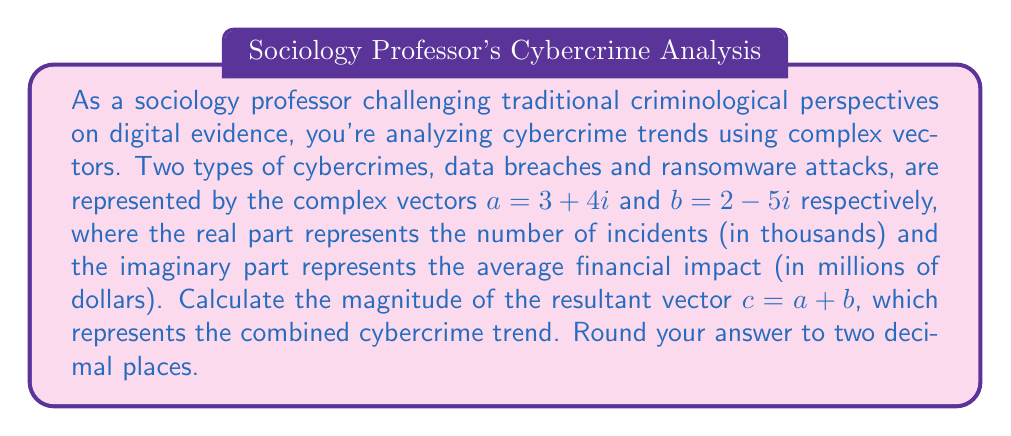Teach me how to tackle this problem. To solve this problem, we'll follow these steps:

1) First, we need to add the two complex vectors:
   $c = a + b = (3 + 4i) + (2 - 5i) = 5 - i$

2) The magnitude of a complex vector $z = x + yi$ is given by the formula:
   $|z| = \sqrt{x^2 + y^2}$

3) For our resultant vector $c = 5 - i$, we have $x = 5$ and $y = -1$

4) Let's substitute these values into the magnitude formula:
   $|c| = \sqrt{5^2 + (-1)^2}$

5) Simplify:
   $|c| = \sqrt{25 + 1} = \sqrt{26}$

6) Calculate the square root and round to two decimal places:
   $|c| \approx 5.10$

This magnitude represents the overall severity of the combined cybercrime trend, taking into account both the number of incidents and the financial impact.
Answer: $5.10$ 